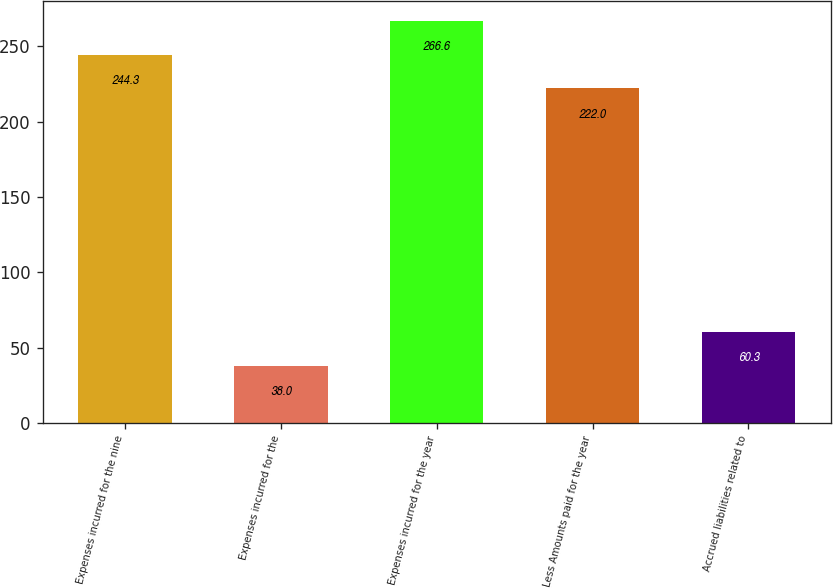Convert chart. <chart><loc_0><loc_0><loc_500><loc_500><bar_chart><fcel>Expenses incurred for the nine<fcel>Expenses incurred for the<fcel>Expenses incurred for the year<fcel>Less Amounts paid for the year<fcel>Accrued liabilities related to<nl><fcel>244.3<fcel>38<fcel>266.6<fcel>222<fcel>60.3<nl></chart> 